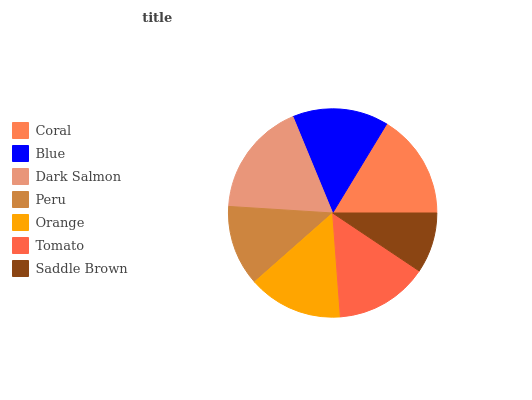Is Saddle Brown the minimum?
Answer yes or no. Yes. Is Dark Salmon the maximum?
Answer yes or no. Yes. Is Blue the minimum?
Answer yes or no. No. Is Blue the maximum?
Answer yes or no. No. Is Coral greater than Blue?
Answer yes or no. Yes. Is Blue less than Coral?
Answer yes or no. Yes. Is Blue greater than Coral?
Answer yes or no. No. Is Coral less than Blue?
Answer yes or no. No. Is Orange the high median?
Answer yes or no. Yes. Is Orange the low median?
Answer yes or no. Yes. Is Peru the high median?
Answer yes or no. No. Is Peru the low median?
Answer yes or no. No. 